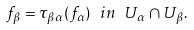Convert formula to latex. <formula><loc_0><loc_0><loc_500><loc_500>f _ { \beta } = \tau _ { \beta \alpha } ( f _ { \alpha } ) \ i n \ U _ { \alpha } \cap U _ { \beta } .</formula> 